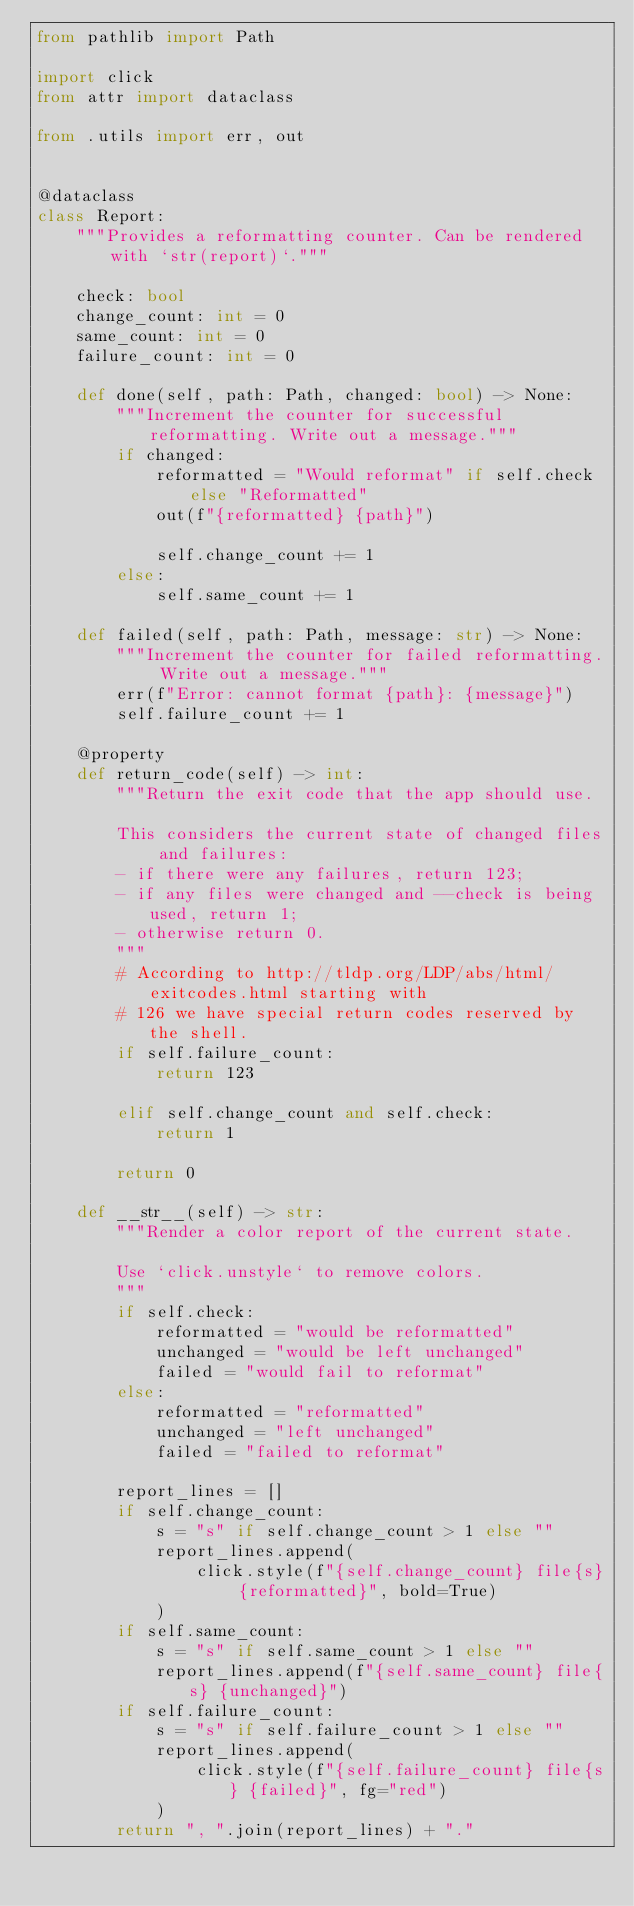Convert code to text. <code><loc_0><loc_0><loc_500><loc_500><_Python_>from pathlib import Path

import click
from attr import dataclass

from .utils import err, out


@dataclass
class Report:
    """Provides a reformatting counter. Can be rendered with `str(report)`."""

    check: bool
    change_count: int = 0
    same_count: int = 0
    failure_count: int = 0

    def done(self, path: Path, changed: bool) -> None:
        """Increment the counter for successful reformatting. Write out a message."""
        if changed:
            reformatted = "Would reformat" if self.check else "Reformatted"
            out(f"{reformatted} {path}")

            self.change_count += 1
        else:
            self.same_count += 1

    def failed(self, path: Path, message: str) -> None:
        """Increment the counter for failed reformatting. Write out a message."""
        err(f"Error: cannot format {path}: {message}")
        self.failure_count += 1

    @property
    def return_code(self) -> int:
        """Return the exit code that the app should use.

        This considers the current state of changed files and failures:
        - if there were any failures, return 123;
        - if any files were changed and --check is being used, return 1;
        - otherwise return 0.
        """
        # According to http://tldp.org/LDP/abs/html/exitcodes.html starting with
        # 126 we have special return codes reserved by the shell.
        if self.failure_count:
            return 123

        elif self.change_count and self.check:
            return 1

        return 0

    def __str__(self) -> str:
        """Render a color report of the current state.

        Use `click.unstyle` to remove colors.
        """
        if self.check:
            reformatted = "would be reformatted"
            unchanged = "would be left unchanged"
            failed = "would fail to reformat"
        else:
            reformatted = "reformatted"
            unchanged = "left unchanged"
            failed = "failed to reformat"

        report_lines = []
        if self.change_count:
            s = "s" if self.change_count > 1 else ""
            report_lines.append(
                click.style(f"{self.change_count} file{s} {reformatted}", bold=True)
            )
        if self.same_count:
            s = "s" if self.same_count > 1 else ""
            report_lines.append(f"{self.same_count} file{s} {unchanged}")
        if self.failure_count:
            s = "s" if self.failure_count > 1 else ""
            report_lines.append(
                click.style(f"{self.failure_count} file{s} {failed}", fg="red")
            )
        return ", ".join(report_lines) + "."
</code> 